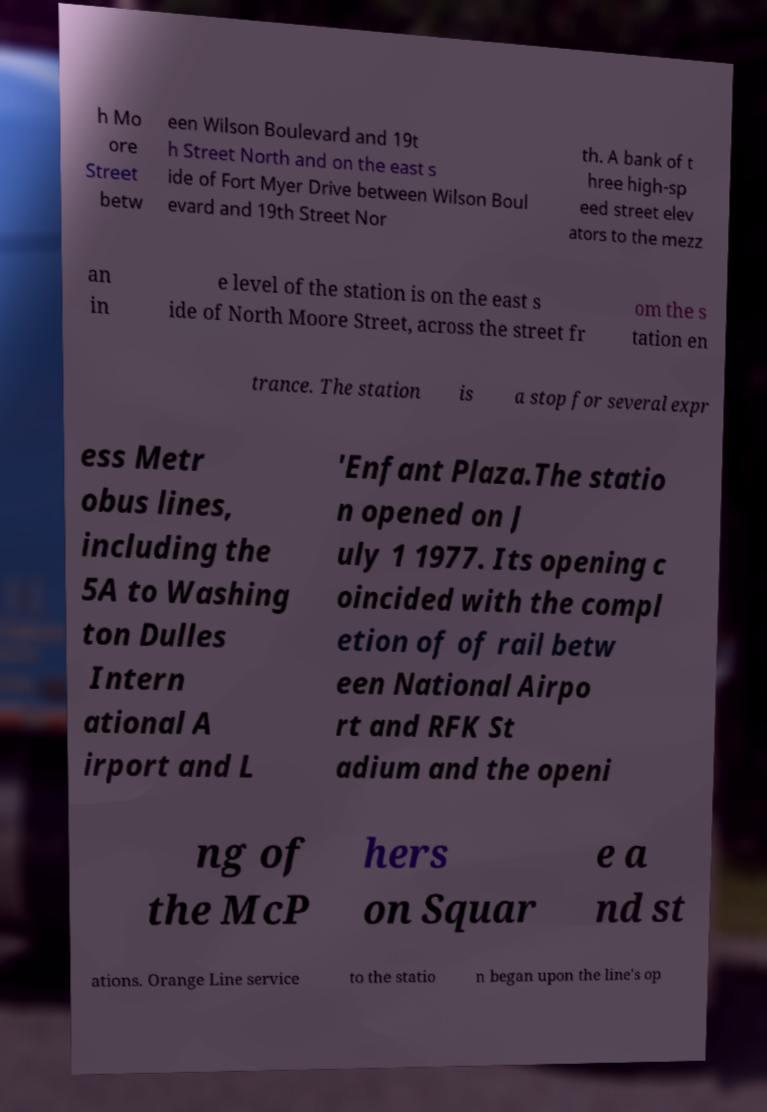I need the written content from this picture converted into text. Can you do that? h Mo ore Street betw een Wilson Boulevard and 19t h Street North and on the east s ide of Fort Myer Drive between Wilson Boul evard and 19th Street Nor th. A bank of t hree high-sp eed street elev ators to the mezz an in e level of the station is on the east s ide of North Moore Street, across the street fr om the s tation en trance. The station is a stop for several expr ess Metr obus lines, including the 5A to Washing ton Dulles Intern ational A irport and L 'Enfant Plaza.The statio n opened on J uly 1 1977. Its opening c oincided with the compl etion of of rail betw een National Airpo rt and RFK St adium and the openi ng of the McP hers on Squar e a nd st ations. Orange Line service to the statio n began upon the line's op 